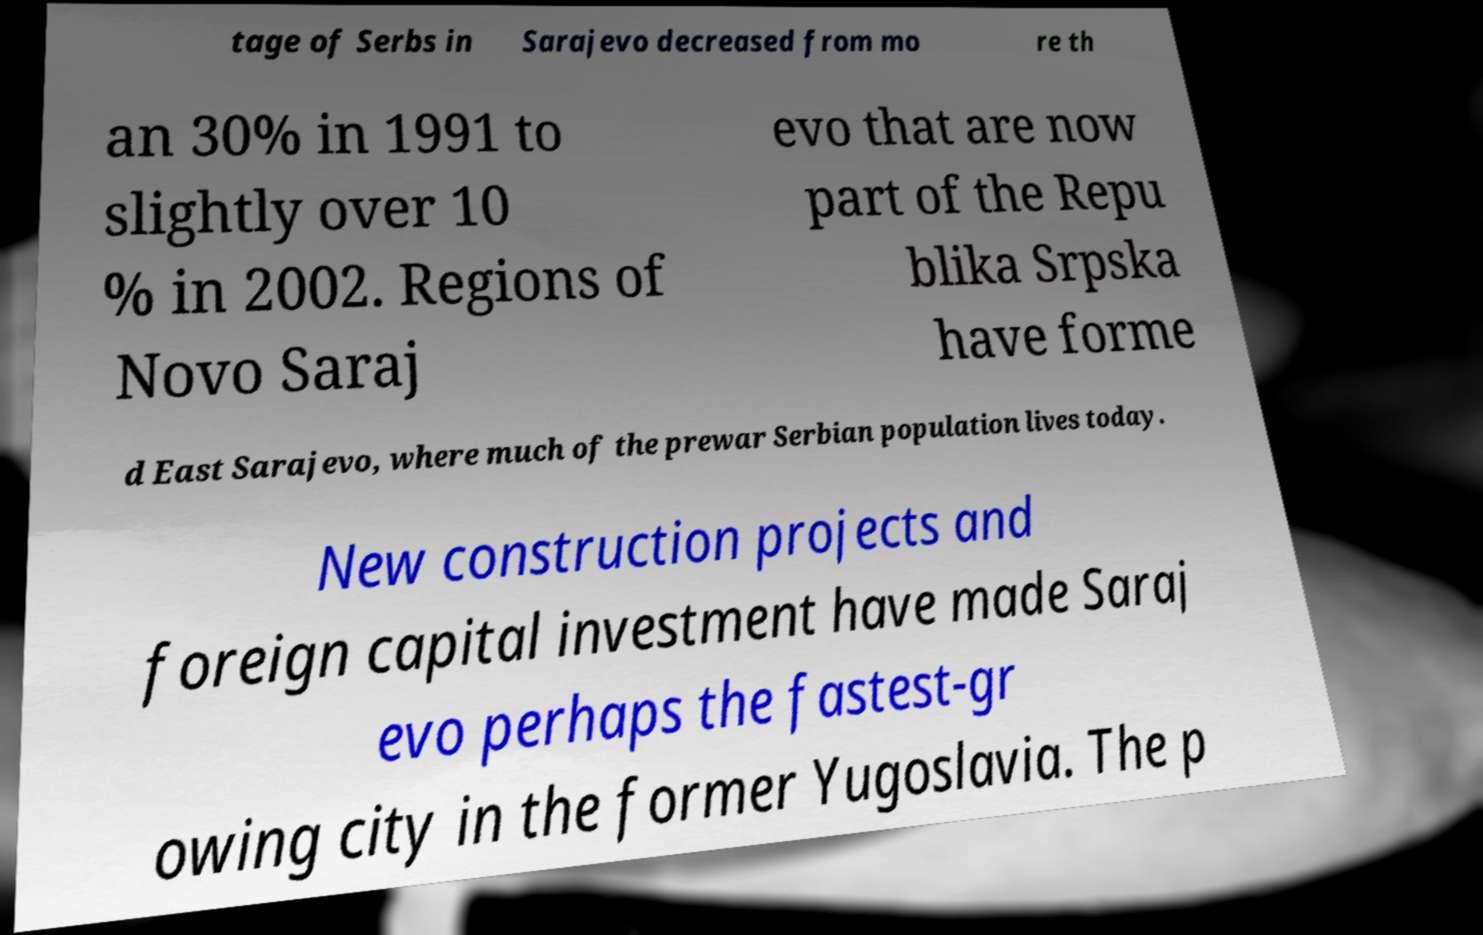Can you accurately transcribe the text from the provided image for me? tage of Serbs in Sarajevo decreased from mo re th an 30% in 1991 to slightly over 10 % in 2002. Regions of Novo Saraj evo that are now part of the Repu blika Srpska have forme d East Sarajevo, where much of the prewar Serbian population lives today. New construction projects and foreign capital investment have made Saraj evo perhaps the fastest-gr owing city in the former Yugoslavia. The p 